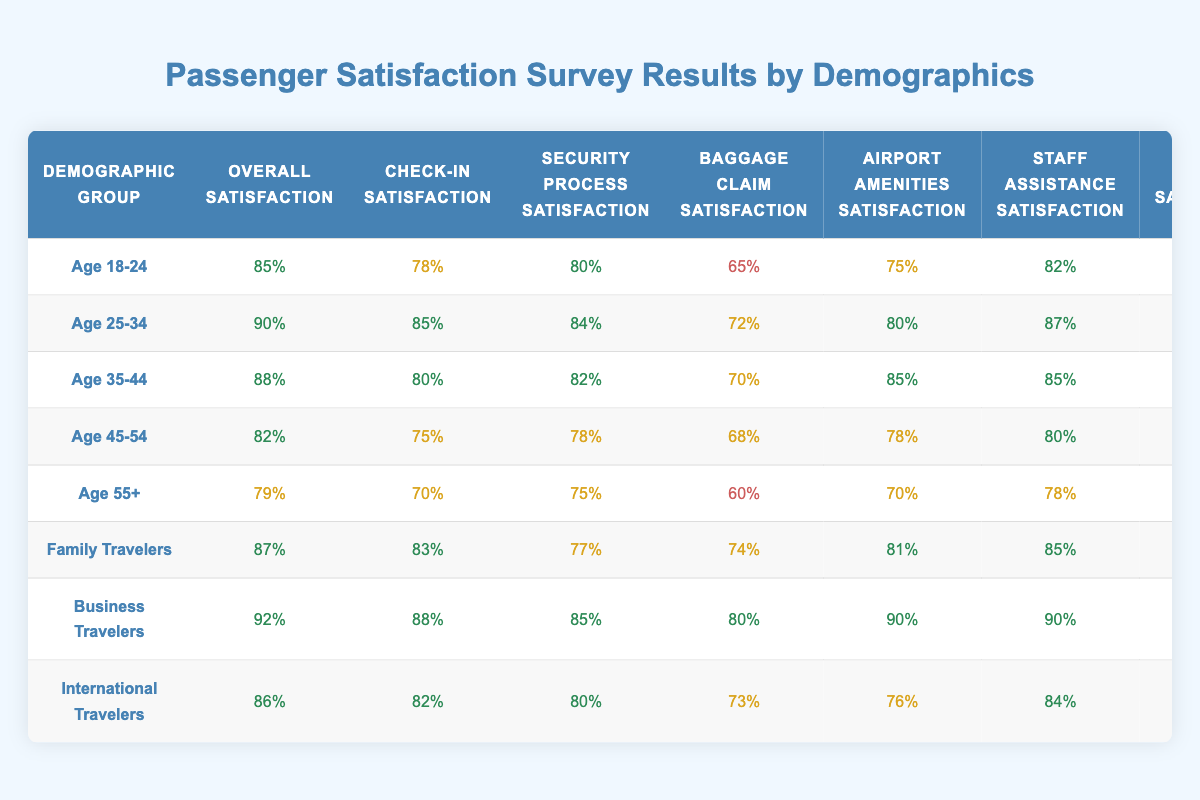What is the overall satisfaction percentage for Business Travelers? The overall satisfaction percentage for Business Travelers is found in the table under their demographic group. It shows 92%.
Answer: 92% Which demographic group has the lowest Baggage Claim Satisfaction? By examining the Baggage Claim Satisfaction values in the table, Age 55+ has the lowest satisfaction at 60%.
Answer: Age 55+ What are the Check-In Satisfaction scores for Family and Business Travelers? The Check-In Satisfaction score for Family Travelers is 83%, and for Business Travelers, it is 88%.
Answer: 83% for Family Travelers and 88% for Business Travelers What is the difference in Overall Satisfaction between Age 25-34 and Age 55+? Age 25-34 has an Overall Satisfaction of 90% and Age 55+ has 79%. The difference is 90% - 79% = 11%.
Answer: 11% Is the Security Process Satisfaction for International Travelers higher than that for Age 35-44? The Security Process Satisfaction for International Travelers is 80% while for Age 35-44 it is also 82%. Since 80% is less than 82%, the statement is false.
Answer: No What is the average WiFi Satisfaction score across all demographic groups? To find the average, we need to sum the WiFi Satisfaction scores of each demographic (88 + 90 + 85 + 80 + 75 + 82 + 95 + 88) = 708. Then divide by the number of groups (8), which gives 708 / 8 = 88.5%.
Answer: 88.5% Which demographic has the highest satisfaction with Airport Amenities? Upon checking the Airport Amenities Satisfaction values, Business Travelers have the highest satisfaction at 90%.
Answer: Business Travelers What is the trend in Check-In Satisfaction from Age 18-24 to Age 55+? Check-In Satisfaction decreases from 78% (Age 18-24) to 70% (Age 55+). The trend is negative.
Answer: Decreases What is the percentage of Staff Assistance Satisfaction for Family Travelers? In the table, the Staff Assistance Satisfaction for Family Travelers is recorded as 85%.
Answer: 85% How does the average Food Options Satisfaction for Age 45-54 and Age 55+ compare to that of Age 25-34? The average Food Options Satisfaction of Age 45-54 (75%) and Age 55+ (72%) is (75% + 72%) / 2 = 73.5%. Age 25-34 has a satisfaction of 80%, thus it's higher.
Answer: Age 25-34 is higher 